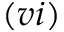<formula> <loc_0><loc_0><loc_500><loc_500>( v i )</formula> 